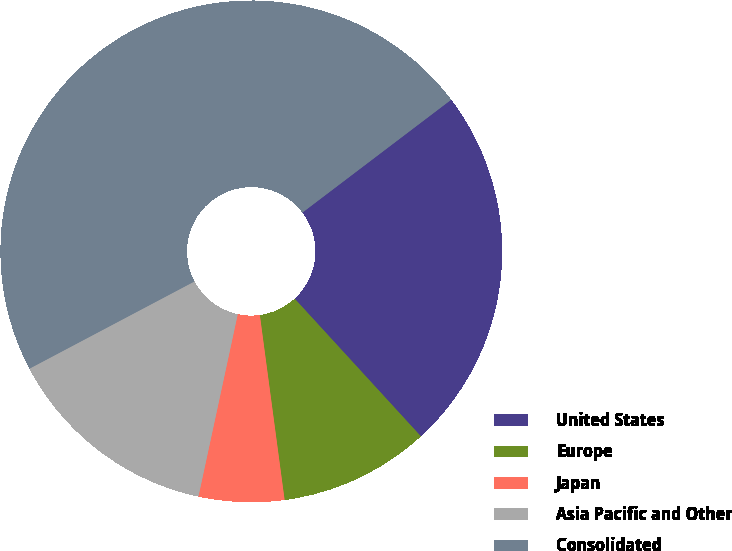Convert chart. <chart><loc_0><loc_0><loc_500><loc_500><pie_chart><fcel>United States<fcel>Europe<fcel>Japan<fcel>Asia Pacific and Other<fcel>Consolidated<nl><fcel>23.52%<fcel>9.69%<fcel>5.5%<fcel>13.88%<fcel>47.41%<nl></chart> 